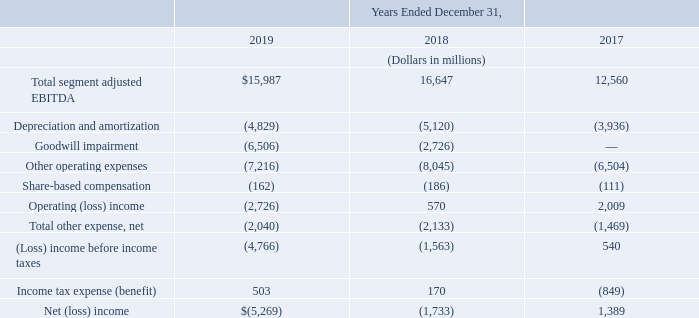The following table reconciles total segment adjusted EBITDA to net (loss) income for the years ended December 31, 2019, 2018 and 2017:
We do not have any single customer that provides more than 10% of our consolidated total operating revenue.
The assets we hold outside of the U.S. represent less than 10% of our total assets. Revenue from sources outside of the U.S. is responsible for less than 10% of our total operating revenue.
What is the Depreciation and amortization for 2019?
Answer scale should be: million. (4,829). What is the total segment adjusted EBITDA in 2019?
Answer scale should be: million. $15,987. What years does the table reconcile total segment adjusted EBITDA to net (loss) income for? 2019, 2018, 2017. Which year has the largest total segment adjusted EBITDA? 16,647>15,987>12,560
Answer: 2018. What is the sum of income tax expense (benefit) in 2018 and 2019?
Answer scale should be: million. 503+170
Answer: 673. What is the percentage change in income tax expense (benefit) in 2019 from 2018?
Answer scale should be: percent. (503-170)/170
Answer: 195.88. 